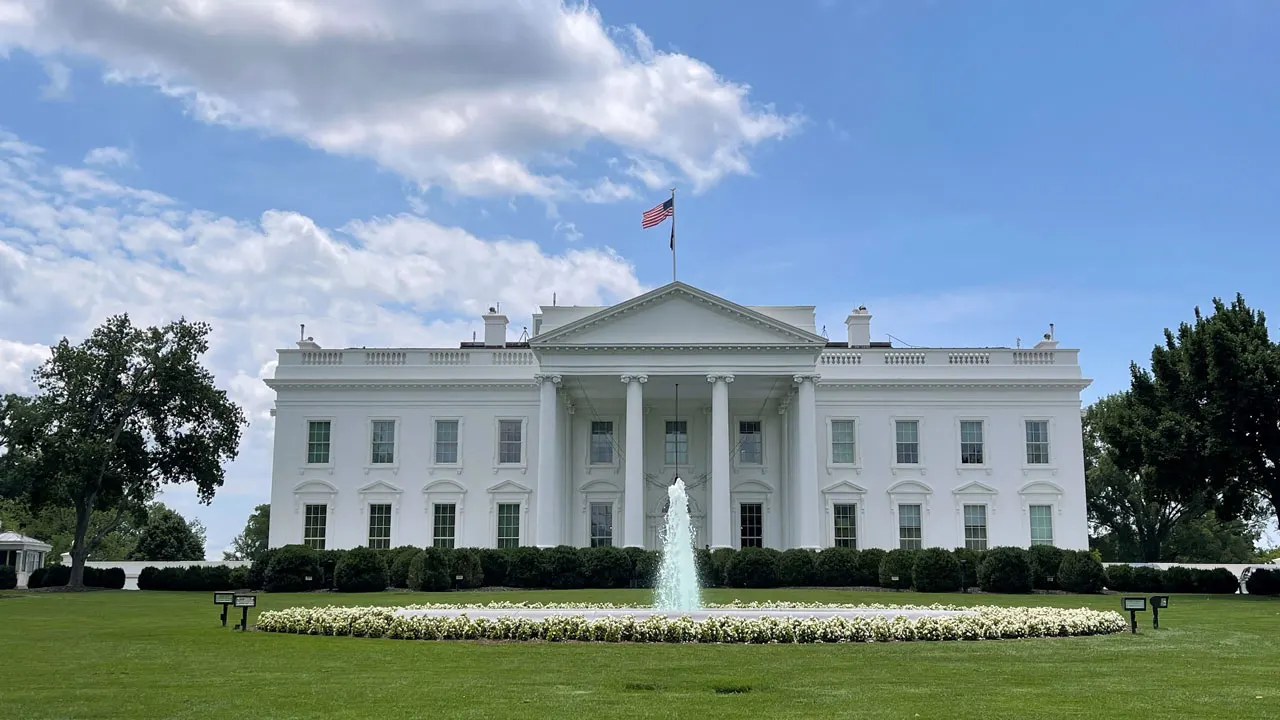Can you elaborate on the elements of the picture provided? The image captures the iconic White House, the official residence and workplace of the president of the United States. The perspective of the photo is from the front lawn, providing a clear view of the building's facade. The White House stands out with its white color, punctuated by columns and windows that add to its architectural grandeur. In the foreground, a fountain adds a touch of elegance to the scene. Above the building, the American flag is seen flying, symbolizing the nation it represents. The sky overhead is a serene blue, dotted with a few clouds, completing the picture of this globally recognized landmark. 